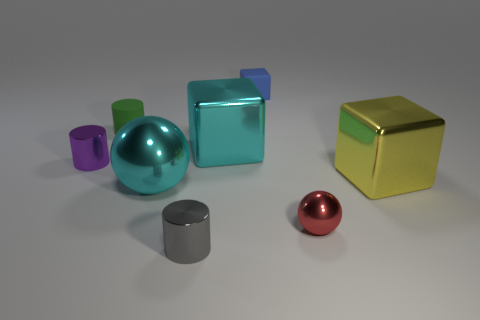There is a rubber thing to the left of the blue cube behind the large thing behind the yellow metallic object; what is its shape?
Your answer should be compact. Cylinder. There is a yellow thing; what number of big yellow metallic blocks are behind it?
Give a very brief answer. 0. Is the big cube that is behind the yellow shiny thing made of the same material as the gray object?
Give a very brief answer. Yes. What number of other things are the same shape as the blue matte object?
Provide a short and direct response. 2. There is a metal cube that is right of the big cyan object that is behind the yellow cube; how many big cyan cubes are behind it?
Your answer should be very brief. 1. There is a metallic ball right of the cyan cube; what color is it?
Ensure brevity in your answer.  Red. Does the matte object that is on the right side of the cyan metallic sphere have the same color as the big metallic ball?
Keep it short and to the point. No. The yellow thing that is the same shape as the blue object is what size?
Give a very brief answer. Large. Is there anything else that is the same size as the cyan metallic ball?
Your answer should be compact. Yes. What is the big cube that is on the right side of the big cyan shiny object behind the cyan metal object on the left side of the gray object made of?
Offer a terse response. Metal. 